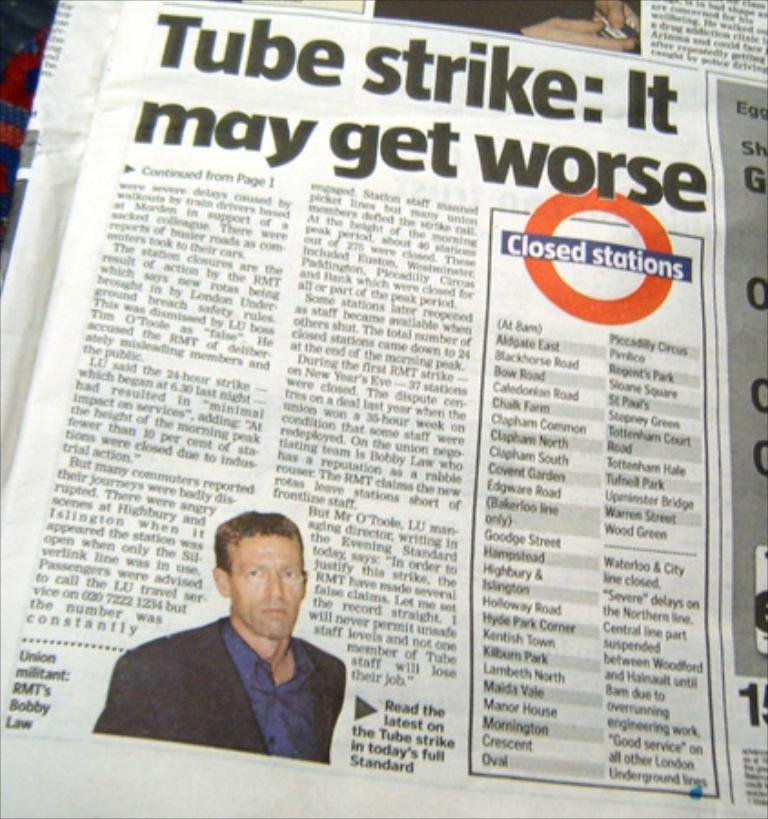<image>
Give a short and clear explanation of the subsequent image. a paper that has the words tube strike in it 